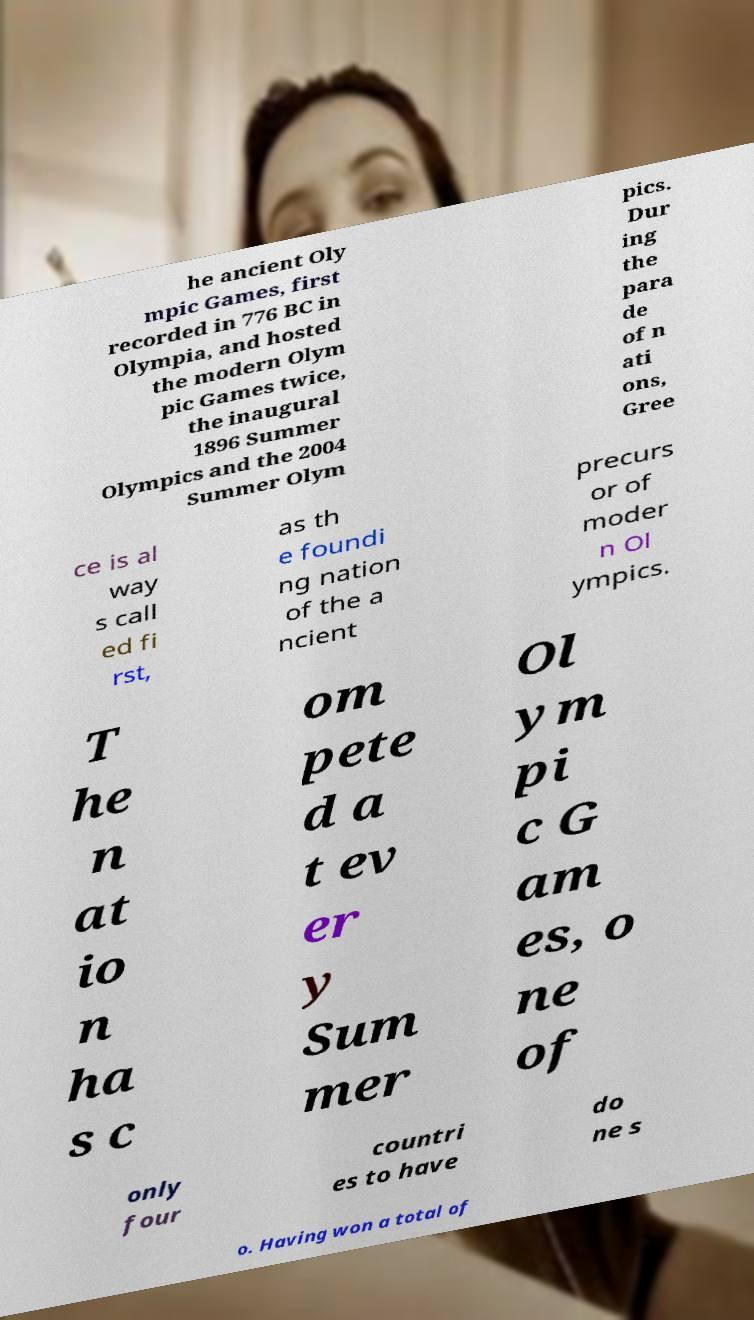Please identify and transcribe the text found in this image. he ancient Oly mpic Games, first recorded in 776 BC in Olympia, and hosted the modern Olym pic Games twice, the inaugural 1896 Summer Olympics and the 2004 Summer Olym pics. Dur ing the para de of n ati ons, Gree ce is al way s call ed fi rst, as th e foundi ng nation of the a ncient precurs or of moder n Ol ympics. T he n at io n ha s c om pete d a t ev er y Sum mer Ol ym pi c G am es, o ne of only four countri es to have do ne s o. Having won a total of 